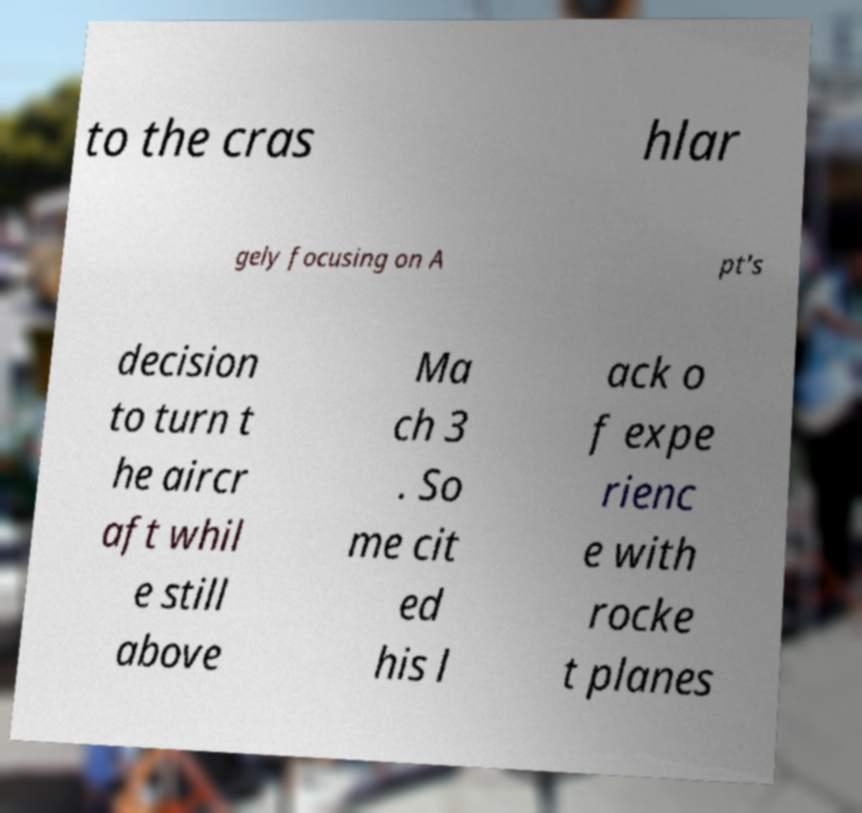Could you assist in decoding the text presented in this image and type it out clearly? to the cras hlar gely focusing on A pt's decision to turn t he aircr aft whil e still above Ma ch 3 . So me cit ed his l ack o f expe rienc e with rocke t planes 